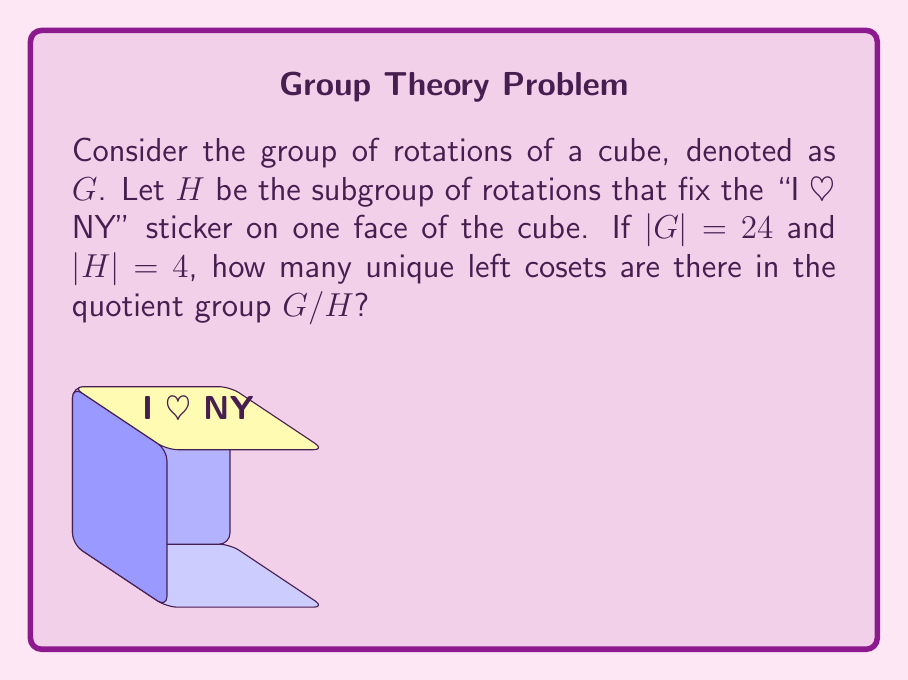Can you solve this math problem? Let's approach this step-by-step:

1) First, recall the Lagrange's Theorem, which states that for a finite group $G$ and a subgroup $H$ of $G$, the order of $H$ divides the order of $G$. 

2) The number of left cosets in $G/H$ is equal to the index of $H$ in $G$, denoted as $[G:H]$.

3) The index $[G:H]$ is given by the formula:

   $$[G:H] = \frac{|G|}{|H|}$$

   where $|G|$ is the order of $G$ and $|H|$ is the order of $H$.

4) We are given that $|G| = 24$ and $|H| = 4$.

5) Substituting these values into the formula:

   $$[G:H] = \frac{24}{4} = 6$$

6) Therefore, there are 6 unique left cosets in the quotient group $G/H$.

Note: This result aligns with the physical interpretation. The rotations that fix the "I ♥ NY" sticker are essentially rotations of the opposite face. There are 6 faces on a cube, corresponding to the 6 cosets.
Answer: 6 